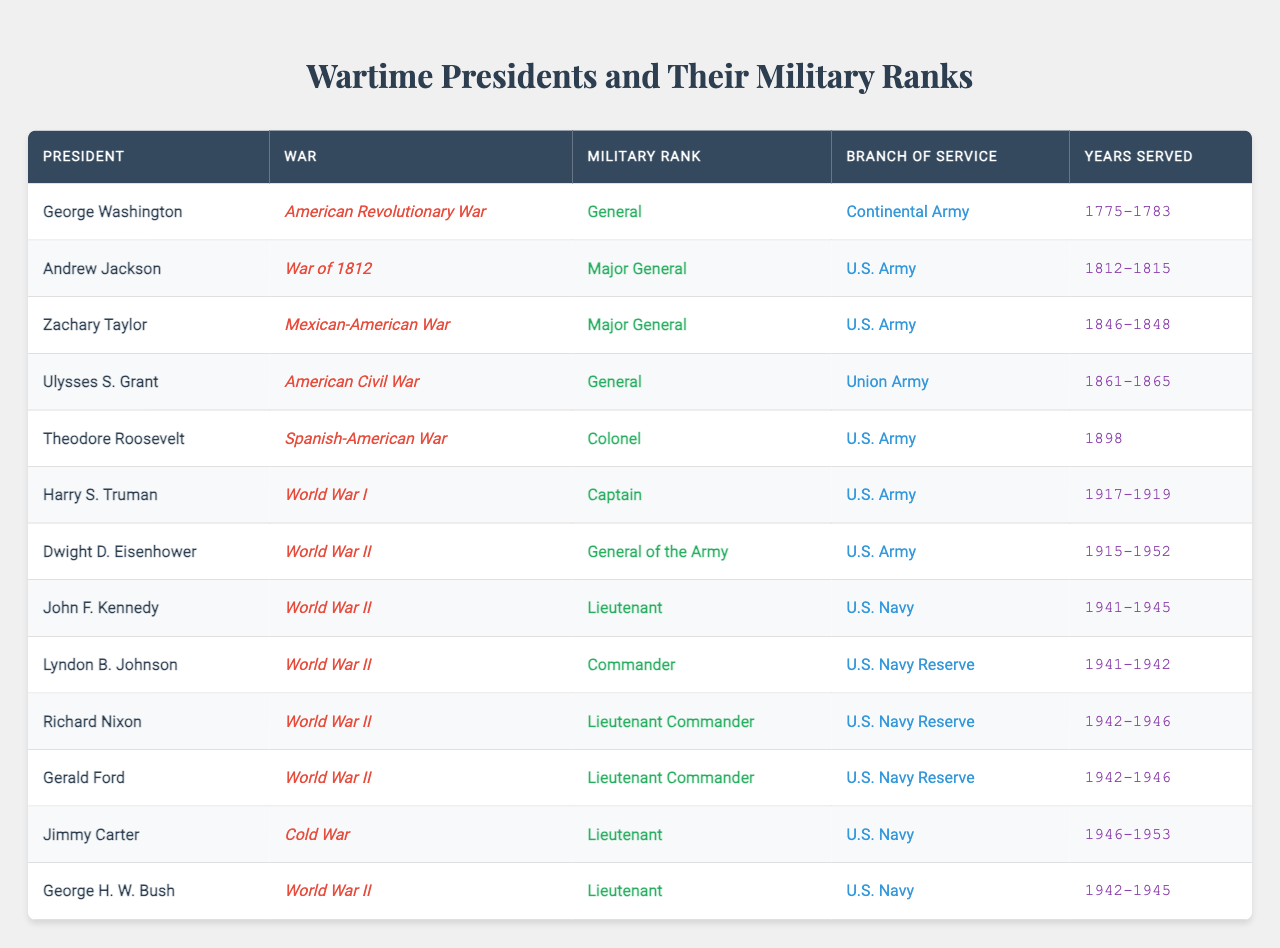What military rank did George Washington hold during the American Revolutionary War? George Washington held the rank of General during the American Revolutionary War, as indicated in the table under the respective columns.
Answer: General Which president served as a Major General during the War of 1812? The table shows that Andrew Jackson served as a Major General during the War of 1812, as listed in the Military Rank column.
Answer: Andrew Jackson How many presidents served in the U.S. Navy during World War II? According to the table, there are three presidents who served in the U.S. Navy during World War II: John F. Kennedy, Lyndon B. Johnson, and Richard Nixon.
Answer: Three Which war had the highest military rank achieved by a president listed in the table? The highest military rank achieved is "General of the Army," held by Dwight D. Eisenhower during World War II. This can be derived from the Military Rank column in the table.
Answer: World War II Did any presidents serve in the Continental Army? Yes, George Washington served in the Continental Army, as indicated in the Branch of Service column next to his name.
Answer: Yes What is the average military rank of the presidents who served in the U.S. Army during wartime? The ranks for the presidents serving in the U.S. Army are Captain (Harry S. Truman), Colonel (Theodore Roosevelt), and Major General (Zachary Taylor and Ulysses S. Grant), which can be converted to a numerical value (Captain=1, Colonel=2, Major General=3). The average is (1 + 2 + 3 + 3) / 4 = 2.25, which corresponds roughly to a Colonel rank.
Answer: Approximately Colonel Which president served in the U.S. Navy Reserve? The table lists Richard Nixon and Gerald Ford as presidents who served in the U.S. Navy Reserve, as shown in the Branch of Service column.
Answer: Richard Nixon and Gerald Ford How many presidents served from 1941 to 1945? The table shows a total of four presidents served during the years 1941 to 1945: John F. Kennedy, Lyndon B. Johnson, Richard Nixon, and George H. W. Bush.
Answer: Four What is the total number of years served by Dwight D. Eisenhower in military service? Dwight D. Eisenhower served from 1915 to 1952, which totals 37 years (calculated by subtracting 1915 from 1952).
Answer: 37 years Which branch of service did most presidents in the table serve? The table indicates that a significant number generally served in the U.S. Army or U.S. Navy. A count shows that four presidents served in the U.S. Army, and four in the U.S. Navy, indicating equal representation.
Answer: Equal representation in U.S. Army and U.S. Navy 